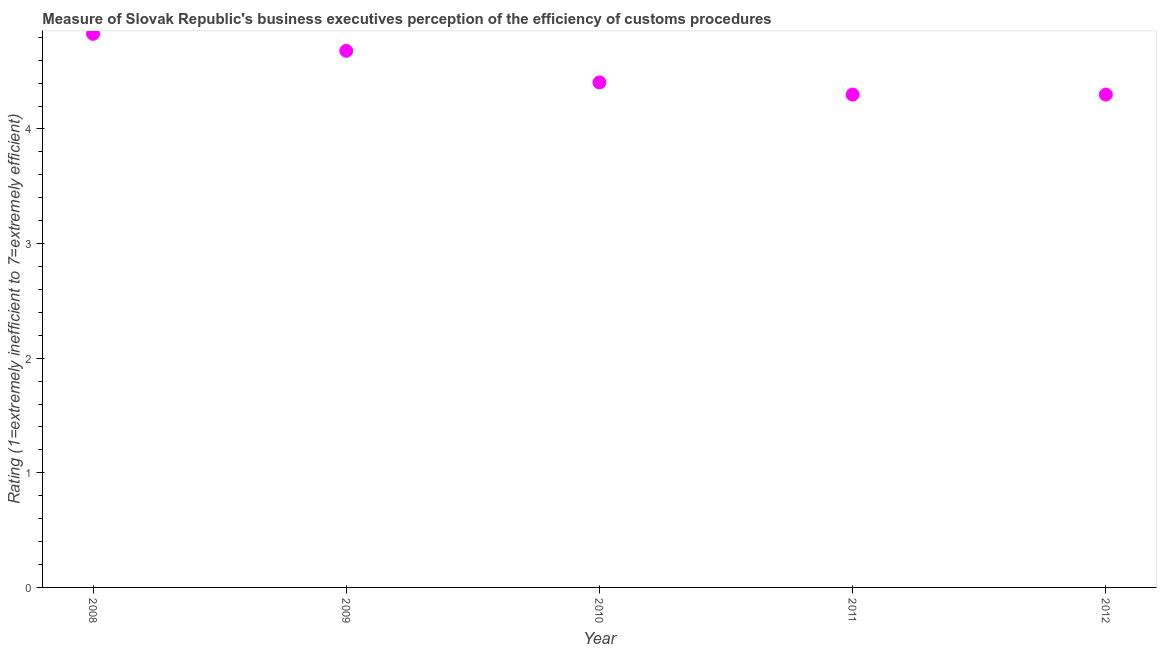What is the rating measuring burden of customs procedure in 2011?
Your answer should be very brief. 4.3. Across all years, what is the maximum rating measuring burden of customs procedure?
Provide a short and direct response. 4.83. In which year was the rating measuring burden of customs procedure maximum?
Give a very brief answer. 2008. In which year was the rating measuring burden of customs procedure minimum?
Keep it short and to the point. 2011. What is the sum of the rating measuring burden of customs procedure?
Your answer should be very brief. 22.52. What is the average rating measuring burden of customs procedure per year?
Give a very brief answer. 4.5. What is the median rating measuring burden of customs procedure?
Ensure brevity in your answer.  4.41. In how many years, is the rating measuring burden of customs procedure greater than 1.2 ?
Make the answer very short. 5. Do a majority of the years between 2012 and 2010 (inclusive) have rating measuring burden of customs procedure greater than 1.4 ?
Offer a very short reply. No. What is the ratio of the rating measuring burden of customs procedure in 2008 to that in 2010?
Offer a very short reply. 1.1. Is the difference between the rating measuring burden of customs procedure in 2008 and 2009 greater than the difference between any two years?
Offer a terse response. No. What is the difference between the highest and the second highest rating measuring burden of customs procedure?
Your response must be concise. 0.15. Is the sum of the rating measuring burden of customs procedure in 2010 and 2011 greater than the maximum rating measuring burden of customs procedure across all years?
Give a very brief answer. Yes. What is the difference between the highest and the lowest rating measuring burden of customs procedure?
Your answer should be compact. 0.53. In how many years, is the rating measuring burden of customs procedure greater than the average rating measuring burden of customs procedure taken over all years?
Provide a succinct answer. 2. Does the rating measuring burden of customs procedure monotonically increase over the years?
Offer a terse response. No. Does the graph contain grids?
Make the answer very short. No. What is the title of the graph?
Make the answer very short. Measure of Slovak Republic's business executives perception of the efficiency of customs procedures. What is the label or title of the X-axis?
Your response must be concise. Year. What is the label or title of the Y-axis?
Your answer should be very brief. Rating (1=extremely inefficient to 7=extremely efficient). What is the Rating (1=extremely inefficient to 7=extremely efficient) in 2008?
Provide a short and direct response. 4.83. What is the Rating (1=extremely inefficient to 7=extremely efficient) in 2009?
Offer a terse response. 4.68. What is the Rating (1=extremely inefficient to 7=extremely efficient) in 2010?
Ensure brevity in your answer.  4.41. What is the Rating (1=extremely inefficient to 7=extremely efficient) in 2012?
Offer a very short reply. 4.3. What is the difference between the Rating (1=extremely inefficient to 7=extremely efficient) in 2008 and 2009?
Give a very brief answer. 0.15. What is the difference between the Rating (1=extremely inefficient to 7=extremely efficient) in 2008 and 2010?
Your answer should be compact. 0.42. What is the difference between the Rating (1=extremely inefficient to 7=extremely efficient) in 2008 and 2011?
Your answer should be compact. 0.53. What is the difference between the Rating (1=extremely inefficient to 7=extremely efficient) in 2008 and 2012?
Provide a short and direct response. 0.53. What is the difference between the Rating (1=extremely inefficient to 7=extremely efficient) in 2009 and 2010?
Provide a succinct answer. 0.28. What is the difference between the Rating (1=extremely inefficient to 7=extremely efficient) in 2009 and 2011?
Keep it short and to the point. 0.38. What is the difference between the Rating (1=extremely inefficient to 7=extremely efficient) in 2009 and 2012?
Your answer should be compact. 0.38. What is the difference between the Rating (1=extremely inefficient to 7=extremely efficient) in 2010 and 2011?
Provide a short and direct response. 0.11. What is the difference between the Rating (1=extremely inefficient to 7=extremely efficient) in 2010 and 2012?
Your answer should be compact. 0.11. What is the difference between the Rating (1=extremely inefficient to 7=extremely efficient) in 2011 and 2012?
Your response must be concise. 0. What is the ratio of the Rating (1=extremely inefficient to 7=extremely efficient) in 2008 to that in 2009?
Ensure brevity in your answer.  1.03. What is the ratio of the Rating (1=extremely inefficient to 7=extremely efficient) in 2008 to that in 2010?
Provide a short and direct response. 1.1. What is the ratio of the Rating (1=extremely inefficient to 7=extremely efficient) in 2008 to that in 2011?
Ensure brevity in your answer.  1.12. What is the ratio of the Rating (1=extremely inefficient to 7=extremely efficient) in 2008 to that in 2012?
Make the answer very short. 1.12. What is the ratio of the Rating (1=extremely inefficient to 7=extremely efficient) in 2009 to that in 2010?
Your response must be concise. 1.06. What is the ratio of the Rating (1=extremely inefficient to 7=extremely efficient) in 2009 to that in 2011?
Your answer should be compact. 1.09. What is the ratio of the Rating (1=extremely inefficient to 7=extremely efficient) in 2009 to that in 2012?
Keep it short and to the point. 1.09. What is the ratio of the Rating (1=extremely inefficient to 7=extremely efficient) in 2010 to that in 2011?
Your answer should be compact. 1.02. 